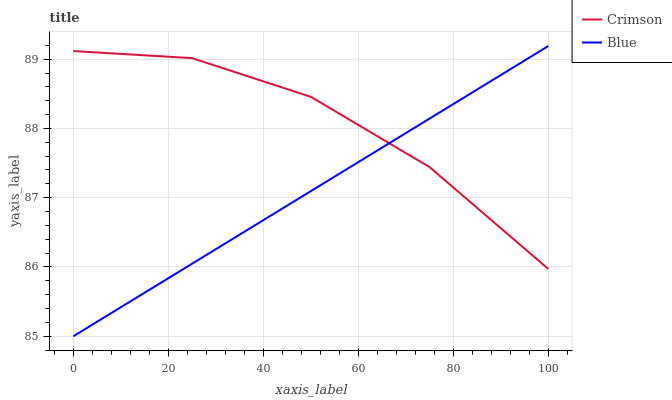Does Blue have the maximum area under the curve?
Answer yes or no. No. Is Blue the roughest?
Answer yes or no. No. 